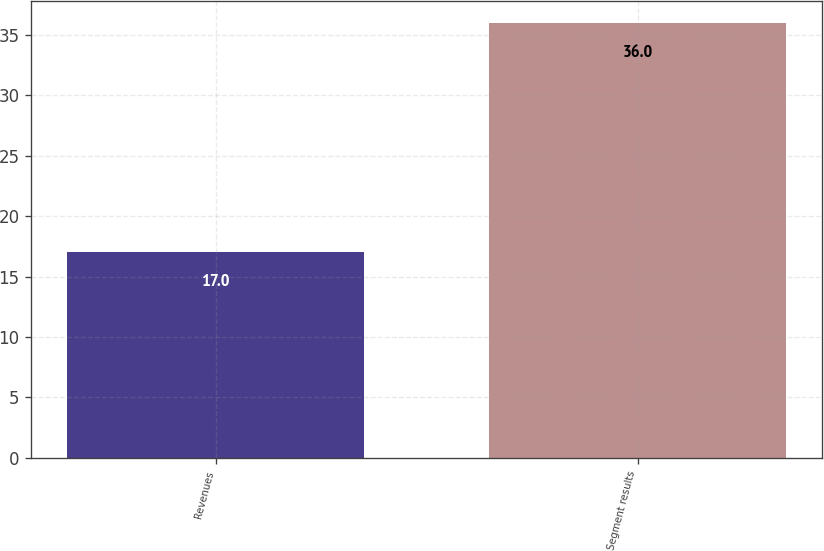Convert chart to OTSL. <chart><loc_0><loc_0><loc_500><loc_500><bar_chart><fcel>Revenues<fcel>Segment results<nl><fcel>17<fcel>36<nl></chart> 